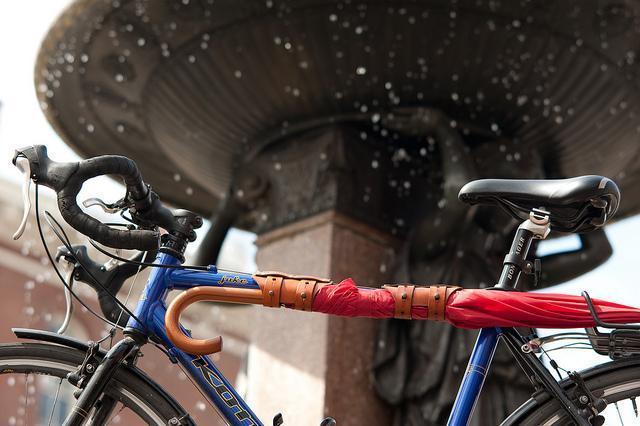How many forks are on the table?
Give a very brief answer. 0. 